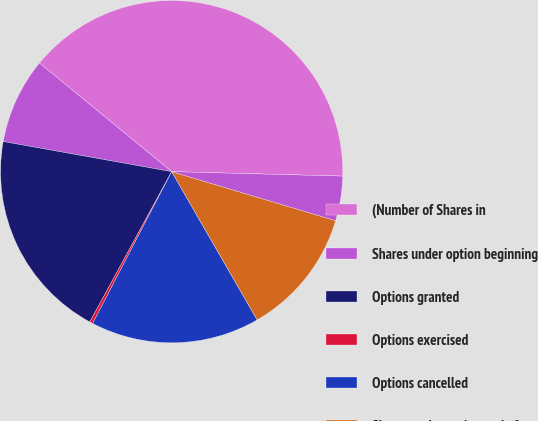Convert chart. <chart><loc_0><loc_0><loc_500><loc_500><pie_chart><fcel>(Number of Shares in<fcel>Shares under option beginning<fcel>Options granted<fcel>Options exercised<fcel>Options cancelled<fcel>Shares under option end of<fcel>Options exercisable at<nl><fcel>39.47%<fcel>8.13%<fcel>19.88%<fcel>0.3%<fcel>15.96%<fcel>12.05%<fcel>4.21%<nl></chart> 